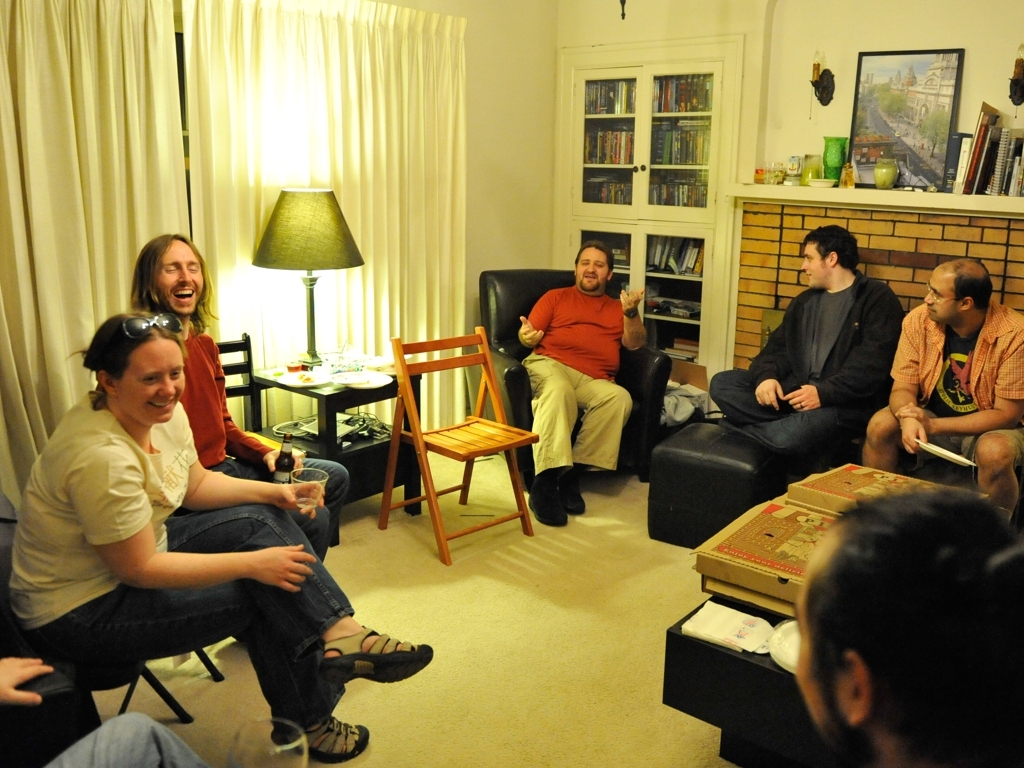Can the main subjects be identified clearly?
A. Yes
B. No
Answer with the option's letter from the given choices directly.
 A. 